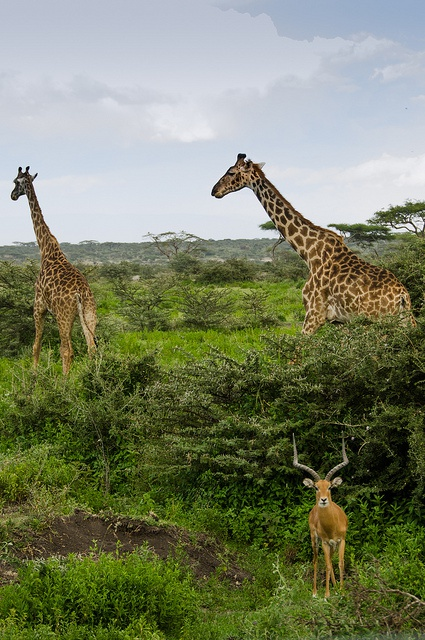Describe the objects in this image and their specific colors. I can see giraffe in lightgray, olive, tan, black, and maroon tones and giraffe in lightgray, olive, tan, and black tones in this image. 